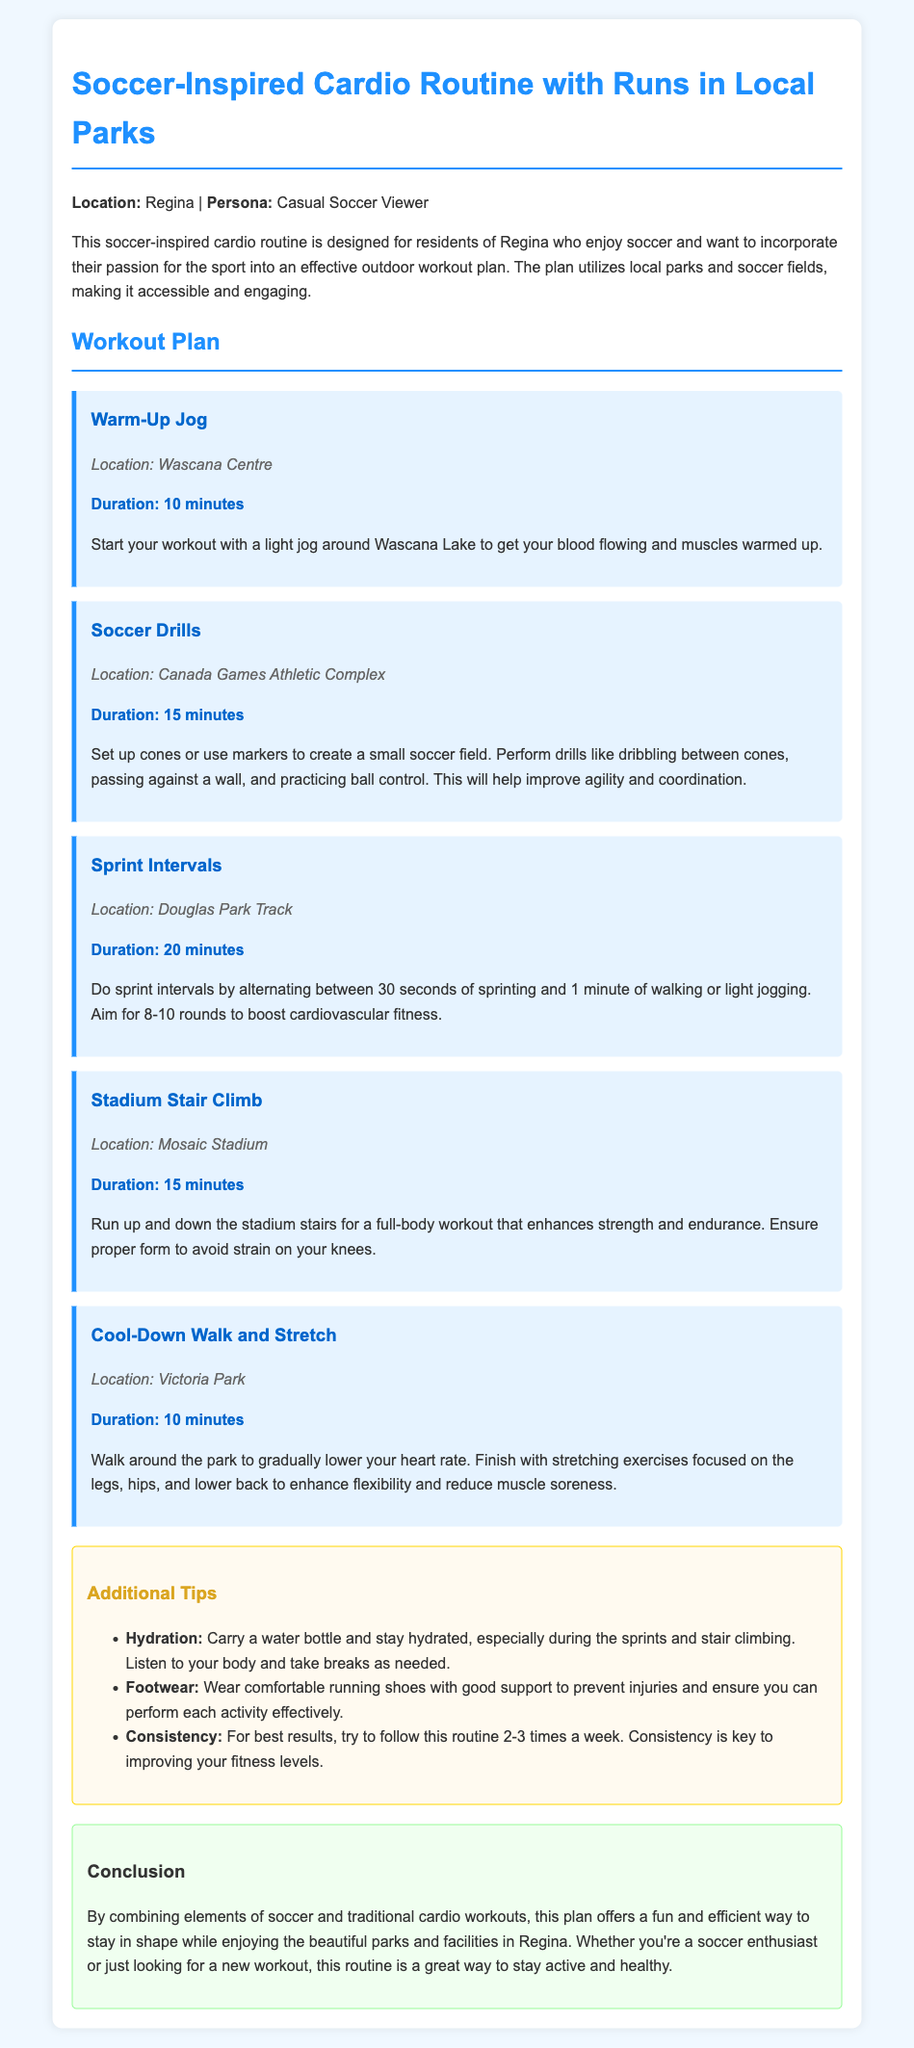what is the duration of the Warm-Up Jog? The duration of the Warm-Up Jog is listed directly in the document as 10 minutes.
Answer: 10 minutes what is the location for Sprint Intervals? The document specifies the location for Sprint Intervals as Douglas Park Track.
Answer: Douglas Park Track how many rounds are suggested for Sprint Intervals? The document suggests aiming for 8-10 rounds of sprint intervals.
Answer: 8-10 rounds what is one piece of advice regarding footwear? The tips section advises wearing comfortable running shoes with good support.
Answer: Comfortable running shoes what is the main goal of the Stadium Stair Climb? The goal is to enhance strength and endurance through running up and down the stadium stairs.
Answer: Enhance strength and endurance which park is recommended for the Cool-Down? The Cool-Down walk and stretch is suggested to be done at Victoria Park.
Answer: Victoria Park how often should this routine be followed for best results? The document mentions trying to follow the routine 2-3 times a week for best results.
Answer: 2-3 times a week what type of workout does this plan combine? The plan combines elements of soccer and traditional cardio workouts for a comprehensive fitness routine.
Answer: Soccer and traditional cardio workouts where can the Soccer Drills be performed? The location for Soccer Drills is specified as Canada Games Athletic Complex in the document.
Answer: Canada Games Athletic Complex 